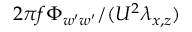<formula> <loc_0><loc_0><loc_500><loc_500>2 \pi f \Phi _ { w ^ { \prime } w ^ { \prime } } / ( U ^ { 2 } \lambda _ { x , z } )</formula> 